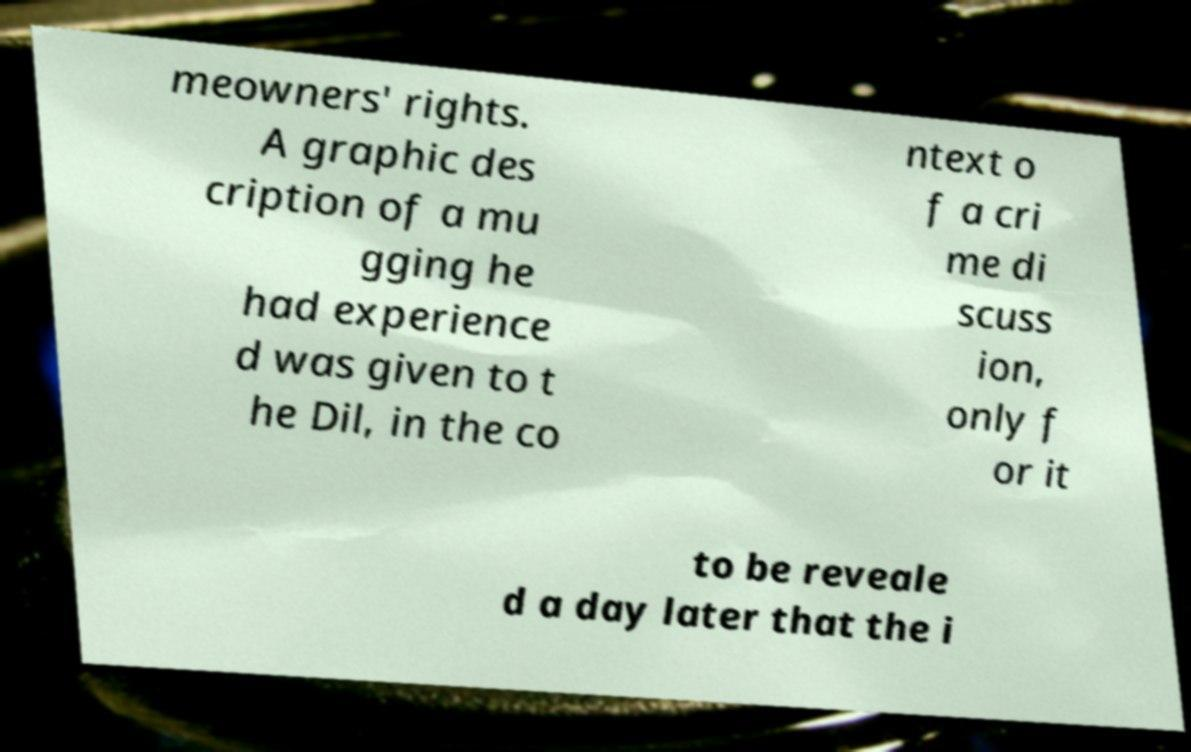Please read and relay the text visible in this image. What does it say? meowners' rights. A graphic des cription of a mu gging he had experience d was given to t he Dil, in the co ntext o f a cri me di scuss ion, only f or it to be reveale d a day later that the i 